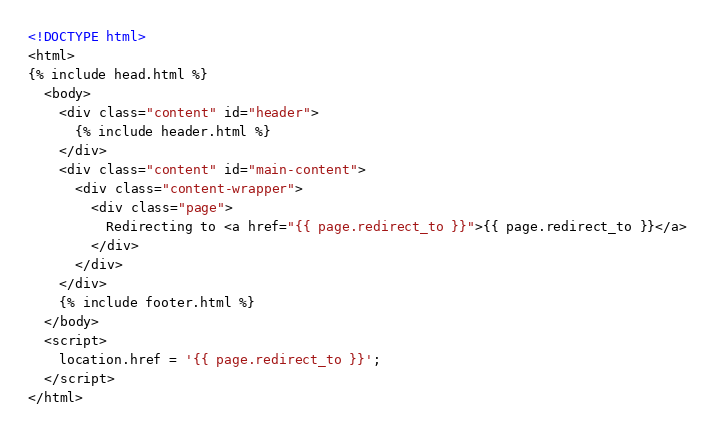Convert code to text. <code><loc_0><loc_0><loc_500><loc_500><_HTML_><!DOCTYPE html>
<html>
{% include head.html %}
  <body>
    <div class="content" id="header">
      {% include header.html %}
    </div>
    <div class="content" id="main-content">
      <div class="content-wrapper">
        <div class="page">
          Redirecting to <a href="{{ page.redirect_to }}">{{ page.redirect_to }}</a>
        </div>
      </div>
    </div>
    {% include footer.html %}
  </body>
  <script>
    location.href = '{{ page.redirect_to }}';
  </script>
</html>
</code> 